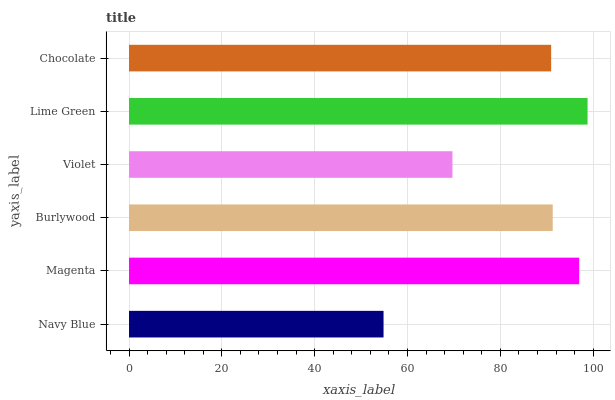Is Navy Blue the minimum?
Answer yes or no. Yes. Is Lime Green the maximum?
Answer yes or no. Yes. Is Magenta the minimum?
Answer yes or no. No. Is Magenta the maximum?
Answer yes or no. No. Is Magenta greater than Navy Blue?
Answer yes or no. Yes. Is Navy Blue less than Magenta?
Answer yes or no. Yes. Is Navy Blue greater than Magenta?
Answer yes or no. No. Is Magenta less than Navy Blue?
Answer yes or no. No. Is Burlywood the high median?
Answer yes or no. Yes. Is Chocolate the low median?
Answer yes or no. Yes. Is Navy Blue the high median?
Answer yes or no. No. Is Violet the low median?
Answer yes or no. No. 